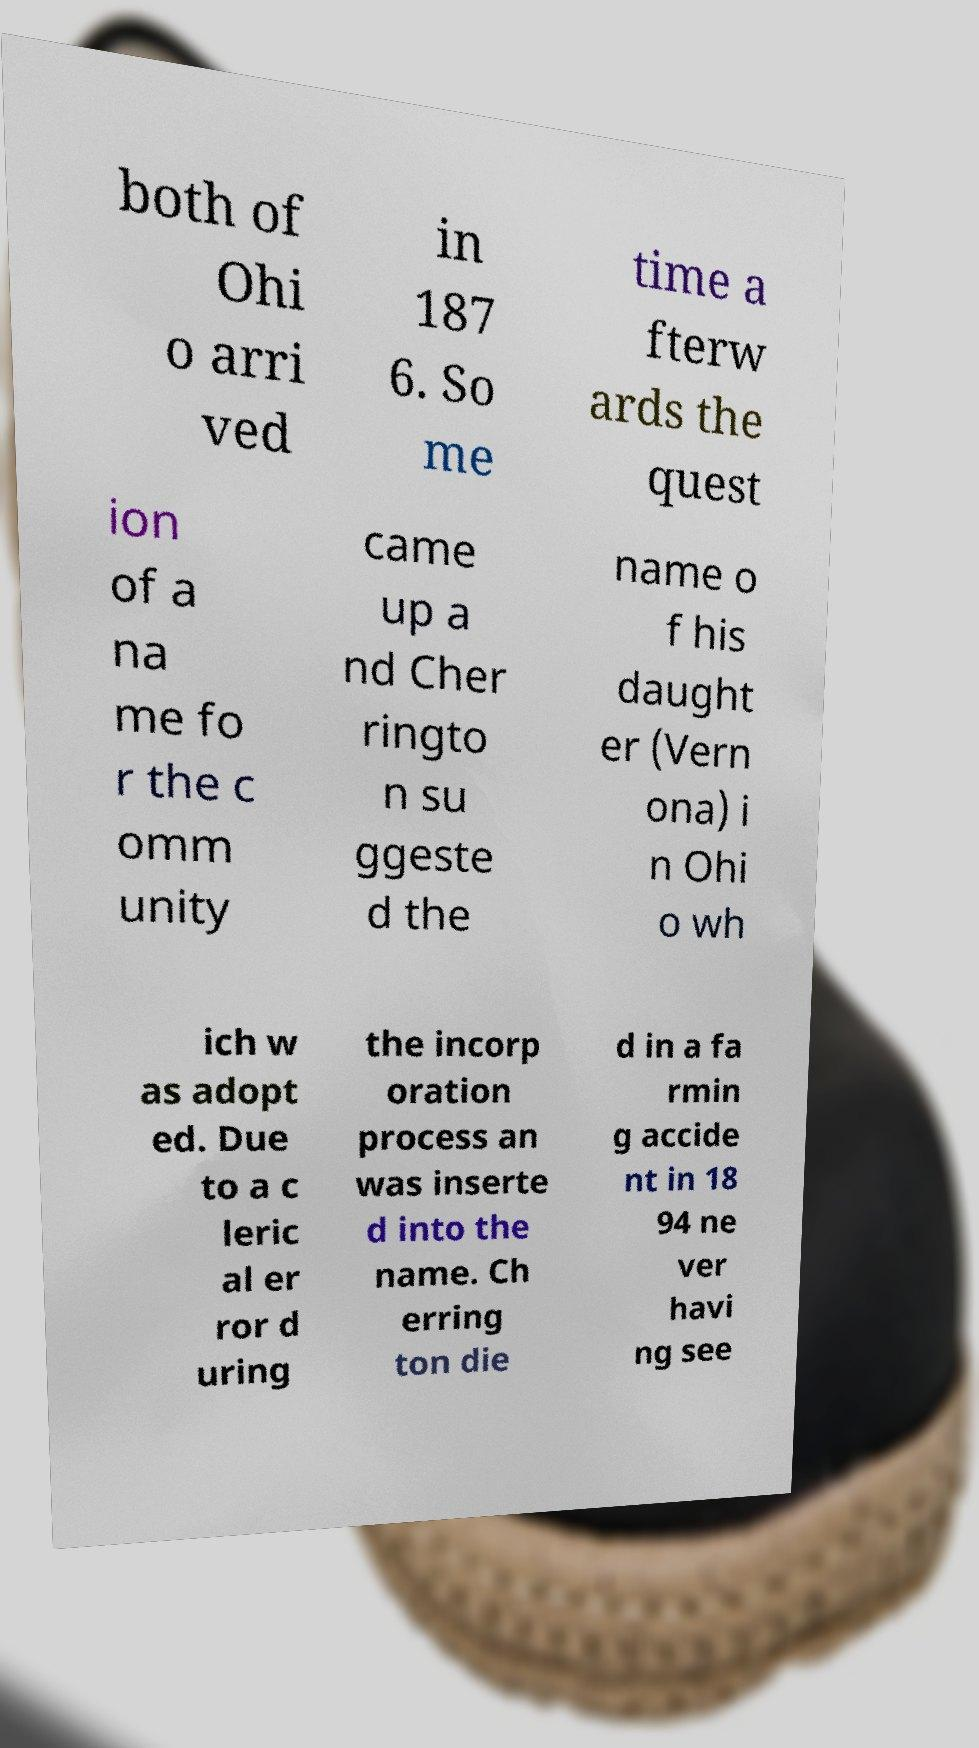Can you accurately transcribe the text from the provided image for me? both of Ohi o arri ved in 187 6. So me time a fterw ards the quest ion of a na me fo r the c omm unity came up a nd Cher ringto n su ggeste d the name o f his daught er (Vern ona) i n Ohi o wh ich w as adopt ed. Due to a c leric al er ror d uring the incorp oration process an was inserte d into the name. Ch erring ton die d in a fa rmin g accide nt in 18 94 ne ver havi ng see 